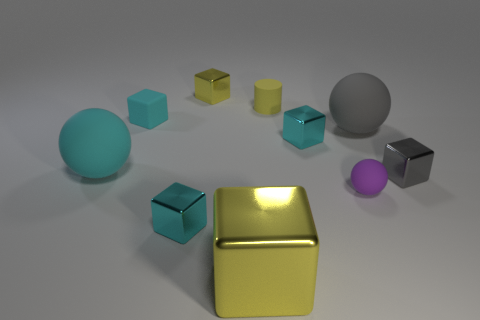Subtract all brown balls. How many cyan cubes are left? 3 Subtract all gray blocks. How many blocks are left? 5 Subtract all cyan rubber blocks. How many blocks are left? 5 Subtract all gray blocks. Subtract all yellow cylinders. How many blocks are left? 5 Subtract all cubes. How many objects are left? 4 Add 9 big cyan rubber balls. How many big cyan rubber balls are left? 10 Add 2 cyan objects. How many cyan objects exist? 6 Subtract 0 brown spheres. How many objects are left? 10 Subtract all large metal objects. Subtract all yellow metal blocks. How many objects are left? 7 